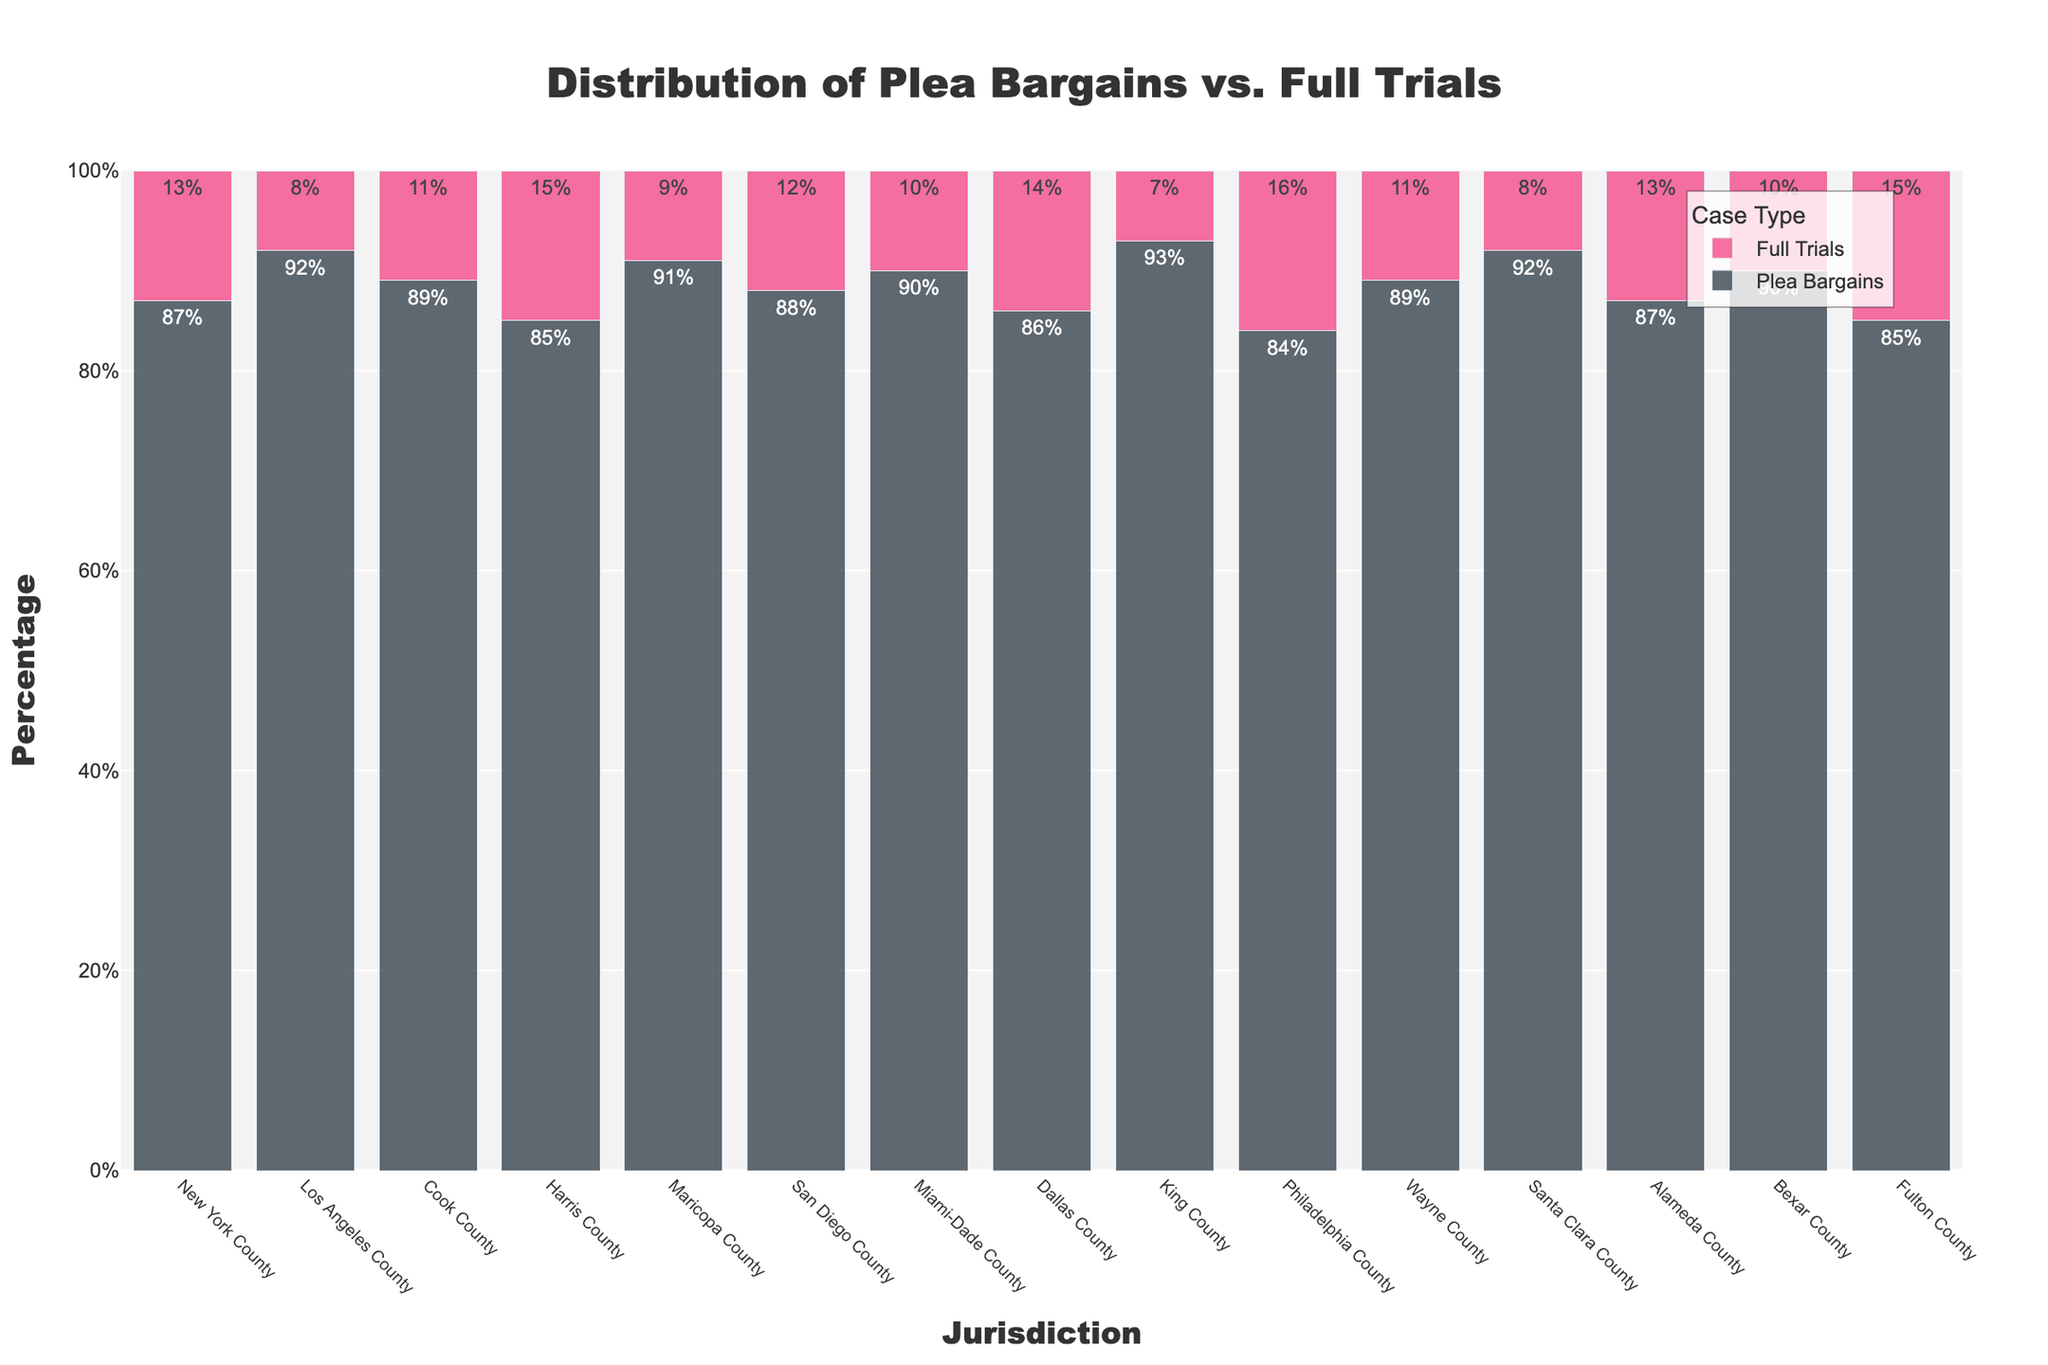Which jurisdiction has the highest percentage of plea bargains? Identify the jurisdiction with the tallest bar in the ‘Plea Bargains’ category. King County has the highest percentage of plea bargains at 93%.
Answer: King County Which jurisdiction has the lowest percentage of full trials? Identify the jurisdiction with the shortest bar in the ‘Full Trials’ category. King County has the lowest percentage of full trials at 7%.
Answer: King County What's the average percentage of full trials across all jurisdictions? Sum the percentages of full trials for all jurisdictions, then divide by the number of jurisdictions. Calculation: (13+8+11+15+9+12+10+14+7+16+11+8+13+10+15) / 15 = 12
Answer: 12 Which jurisdictions have a higher percentage of full trials than Harris County? Compare the full trials percentage of each jurisdiction with Harris County's 15%. Philadelphia County and Fulton County have higher percentages than Harris County.
Answer: Philadelphia County and Fulton County What is the total percentage of plea bargains and full trials in Dallas County? Sum the percentages of plea bargains and full trials for Dallas County. Calculation: 86 + 14 = 100
Answer: 100 Which jurisdiction shows an equal proportion of plea bargains and full trials? Identify if any jurisdiction has both bars approximately equal in height. No jurisdiction has equal bars for plea bargains and full trials.
Answer: None Between Los Angeles County and Miami-Dade County, which has a higher percentage of full trials? Compare the height of the full trial bars for Los Angeles County (8%) and Miami-Dade County (10%). Miami-Dade County has a higher percentage.
Answer: Miami-Dade County Which two jurisdictions have the same percentage of plea bargains? Identify the jurisdictions with the same height bars in the ‘Plea Bargains’ category. Los Angeles County and Santa Clara County both have 92%.
Answer: Los Angeles County and Santa Clara County What's the difference in the percentage of plea bargains between Wayne County and San Diego County? Subtract Wayne County’s percentage (89%) from San Diego County’s (88%). Calculation: 89 - 88 = 1
Answer: 1 